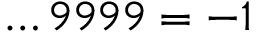Convert formula to latex. <formula><loc_0><loc_0><loc_500><loc_500>\dots 9 9 9 9 = - 1</formula> 